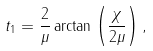Convert formula to latex. <formula><loc_0><loc_0><loc_500><loc_500>t _ { 1 } = \frac { 2 } { \mu } \arctan \left ( \frac { \chi } { 2 \mu } \right ) ,</formula> 